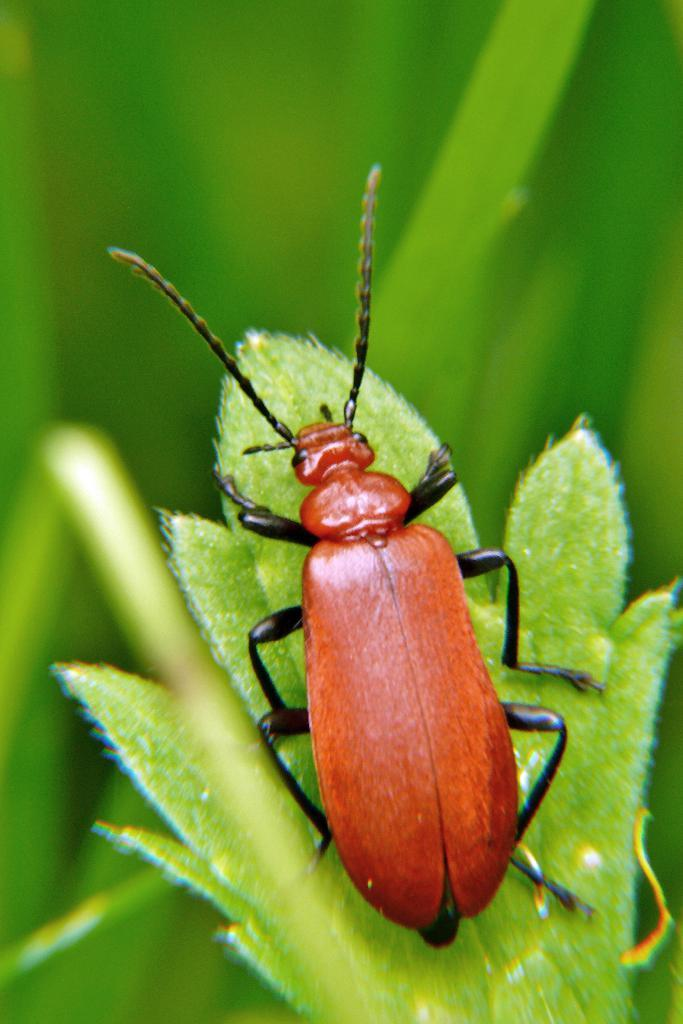What is present on the green leaf in the image? There is an insect on the green leaf in the image. Can you describe the insect's location in the image? The insect is on a green leaf in the image. What can be observed about the background of the image? The background of the image is blurry. What type of drink is being served in the tub in the image? There is no tub or drink present in the image; it features an insect on a green leaf with a blurry background. 